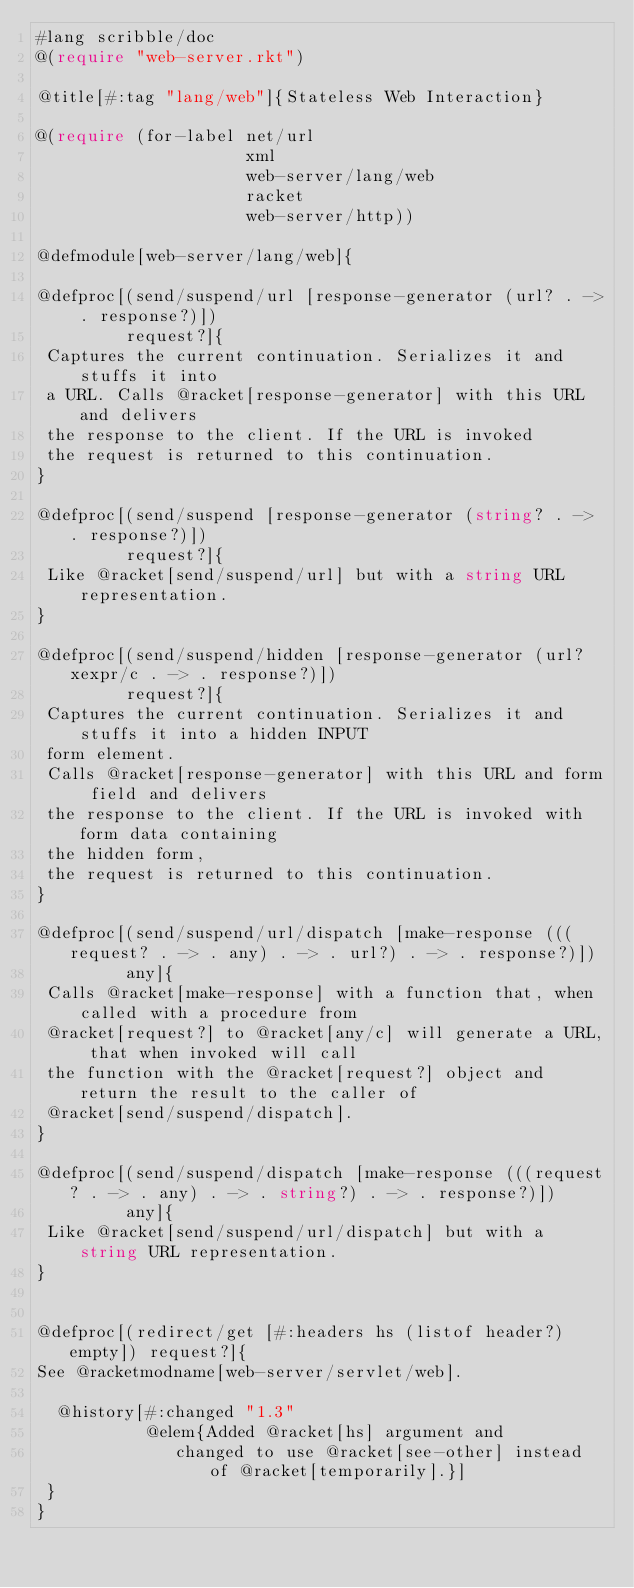<code> <loc_0><loc_0><loc_500><loc_500><_Racket_>#lang scribble/doc
@(require "web-server.rkt")

@title[#:tag "lang/web"]{Stateless Web Interaction}

@(require (for-label net/url
                     xml
                     web-server/lang/web
                     racket
                     web-server/http))

@defmodule[web-server/lang/web]{

@defproc[(send/suspend/url [response-generator (url? . -> . response?)])
         request?]{
 Captures the current continuation. Serializes it and stuffs it into
 a URL. Calls @racket[response-generator] with this URL and delivers
 the response to the client. If the URL is invoked
 the request is returned to this continuation.
}
                  
@defproc[(send/suspend [response-generator (string? . -> . response?)])
         request?]{
 Like @racket[send/suspend/url] but with a string URL representation.
}

@defproc[(send/suspend/hidden [response-generator (url? xexpr/c . -> . response?)])
         request?]{
 Captures the current continuation. Serializes it and stuffs it into a hidden INPUT
 form element.
 Calls @racket[response-generator] with this URL and form field and delivers
 the response to the client. If the URL is invoked with form data containing
 the hidden form,
 the request is returned to this continuation.
}

@defproc[(send/suspend/url/dispatch [make-response (((request? . -> . any) . -> . url?) . -> . response?)])
         any]{
 Calls @racket[make-response] with a function that, when called with a procedure from
 @racket[request?] to @racket[any/c] will generate a URL, that when invoked will call
 the function with the @racket[request?] object and return the result to the caller of
 @racket[send/suspend/dispatch].
}
               
@defproc[(send/suspend/dispatch [make-response (((request? . -> . any) . -> . string?) . -> . response?)])
         any]{
 Like @racket[send/suspend/url/dispatch] but with a string URL representation.
}


@defproc[(redirect/get [#:headers hs (listof header?) empty]) request?]{
See @racketmodname[web-server/servlet/web].

  @history[#:changed "1.3"
           @elem{Added @racket[hs] argument and
              changed to use @racket[see-other] instead of @racket[temporarily].}]
 }
}
</code> 